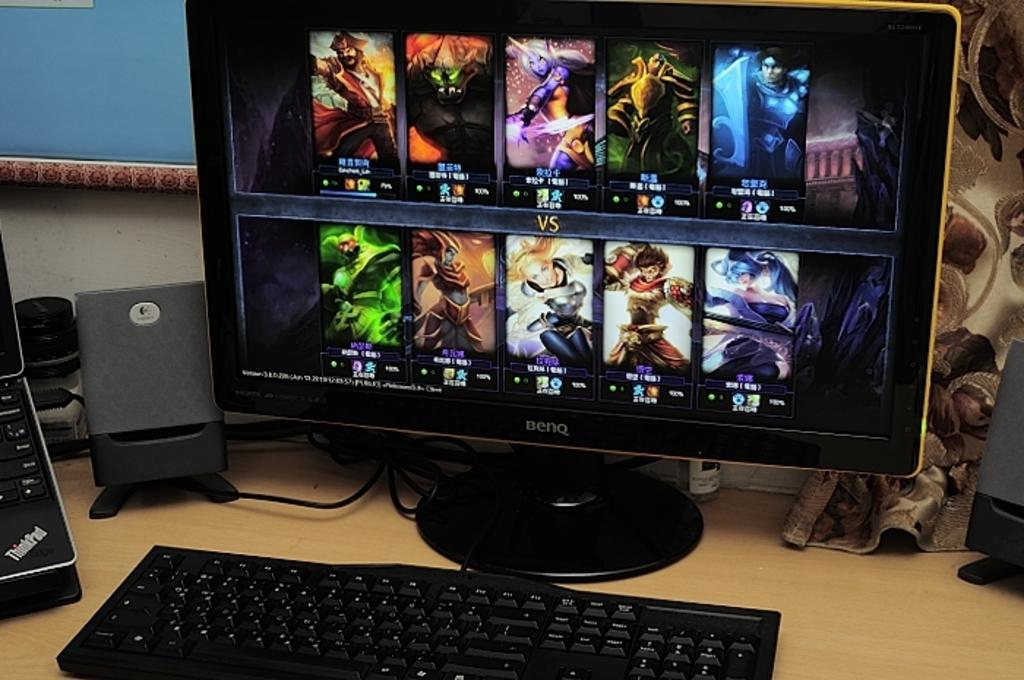Provide a one-sentence caption for the provided image. The brand of the computer monitor is BENQ. 